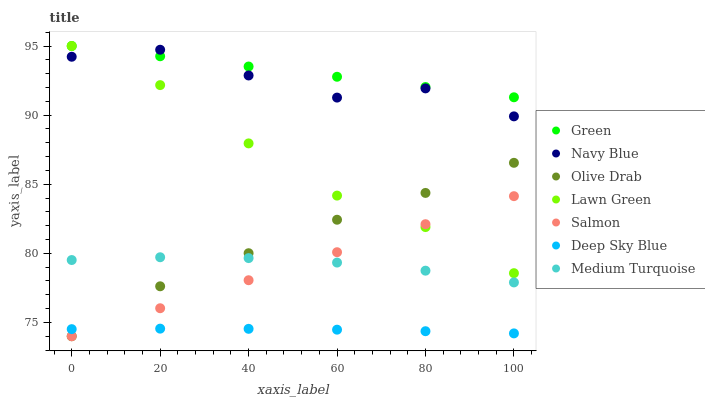Does Deep Sky Blue have the minimum area under the curve?
Answer yes or no. Yes. Does Green have the maximum area under the curve?
Answer yes or no. Yes. Does Medium Turquoise have the minimum area under the curve?
Answer yes or no. No. Does Medium Turquoise have the maximum area under the curve?
Answer yes or no. No. Is Salmon the smoothest?
Answer yes or no. Yes. Is Navy Blue the roughest?
Answer yes or no. Yes. Is Medium Turquoise the smoothest?
Answer yes or no. No. Is Medium Turquoise the roughest?
Answer yes or no. No. Does Salmon have the lowest value?
Answer yes or no. Yes. Does Medium Turquoise have the lowest value?
Answer yes or no. No. Does Green have the highest value?
Answer yes or no. Yes. Does Medium Turquoise have the highest value?
Answer yes or no. No. Is Medium Turquoise less than Green?
Answer yes or no. Yes. Is Lawn Green greater than Deep Sky Blue?
Answer yes or no. Yes. Does Green intersect Lawn Green?
Answer yes or no. Yes. Is Green less than Lawn Green?
Answer yes or no. No. Is Green greater than Lawn Green?
Answer yes or no. No. Does Medium Turquoise intersect Green?
Answer yes or no. No. 